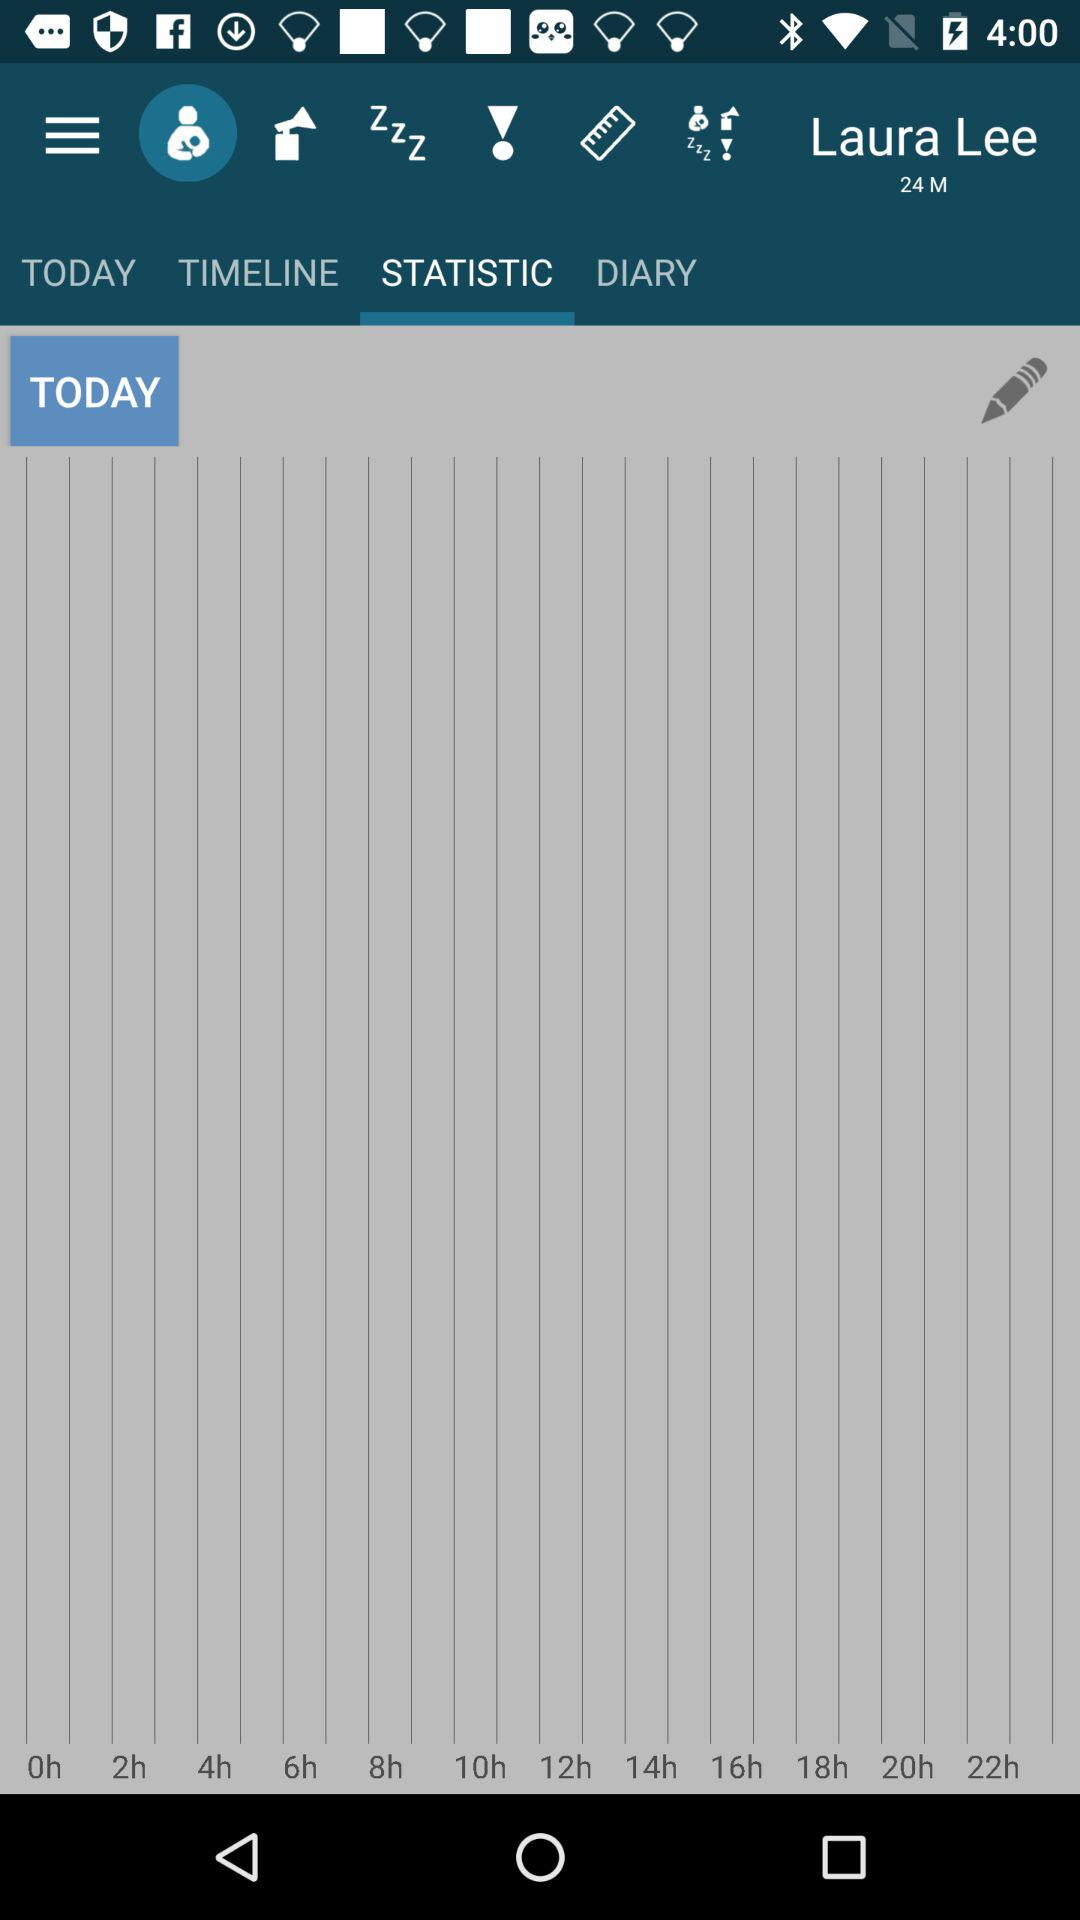Which tab is selected? The selected tab is "STATISTIC". 